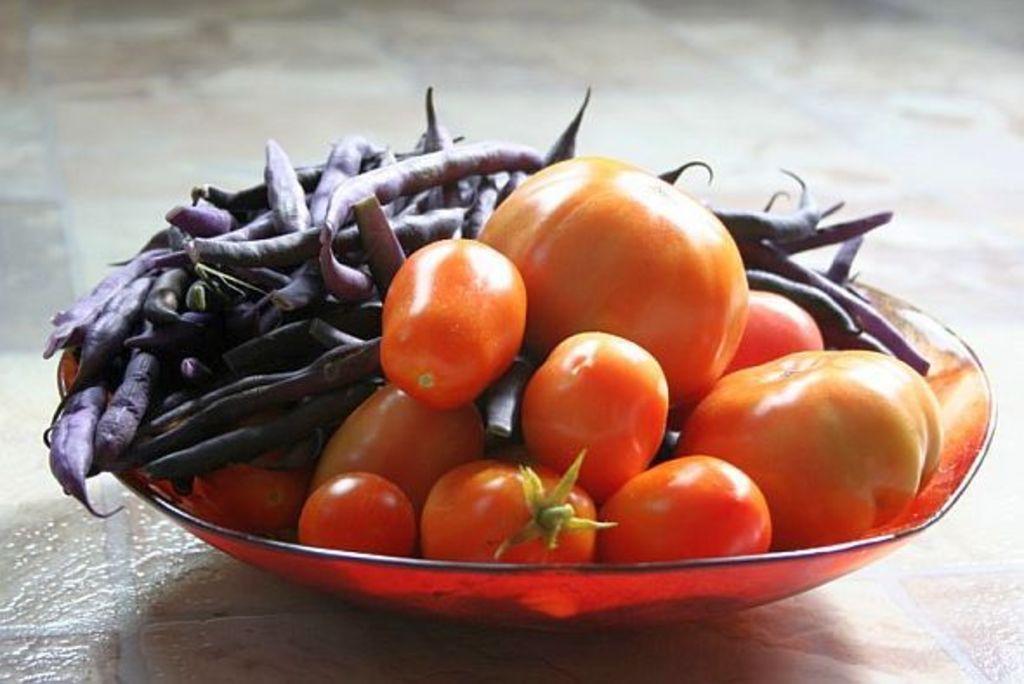Describe this image in one or two sentences. In this picture we can see a bowl with tomatoes and beans in it and this bowl is placed on a platform. 